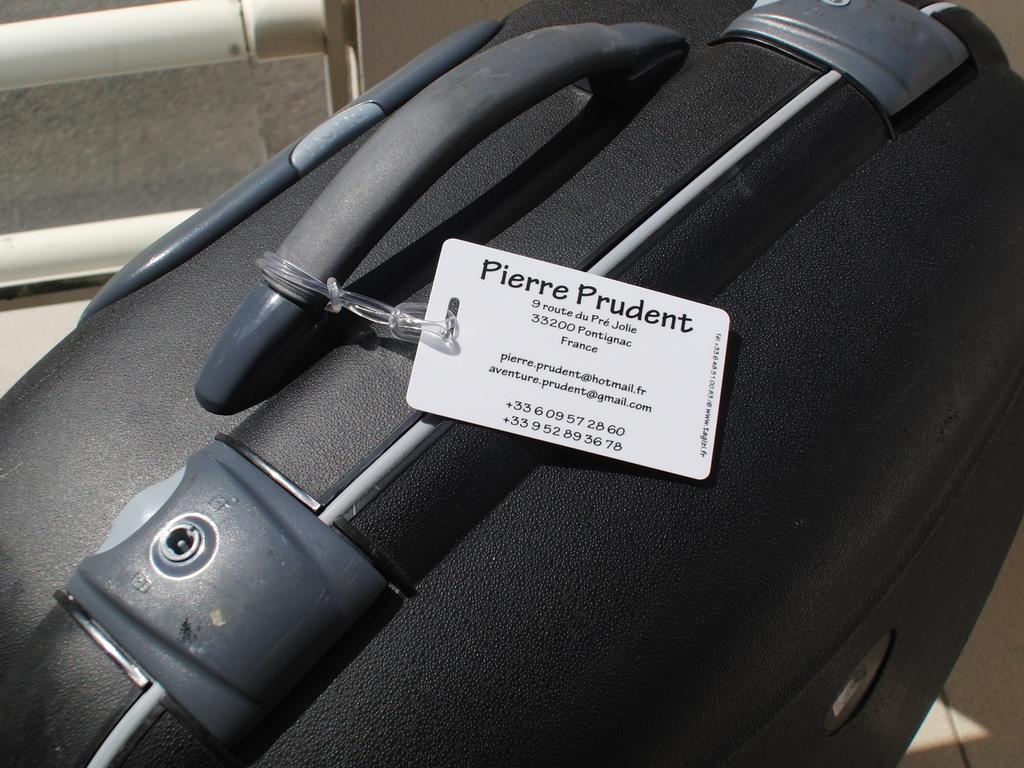What object can be seen in the image that is commonly used for traveling? There is a suitcase in the image that is commonly used for traveling. What feature does the suitcase have to secure its contents? The suitcase has a lock system to secure its contents. Is there any additional information about the suitcase provided in the image? Yes, there is a price tag attached to the handle of the suitcase. Can you see any zebras on the roof of the suitcase in the image? No, there are no zebras or any other animals present on the suitcase or its surroundings in the image. 